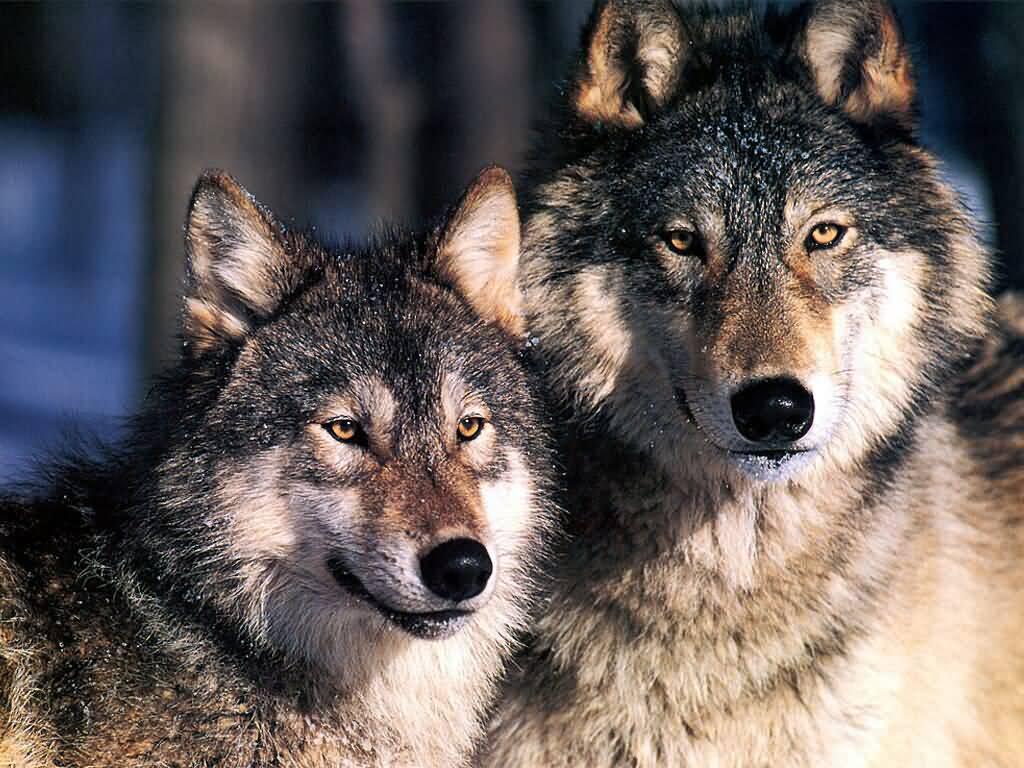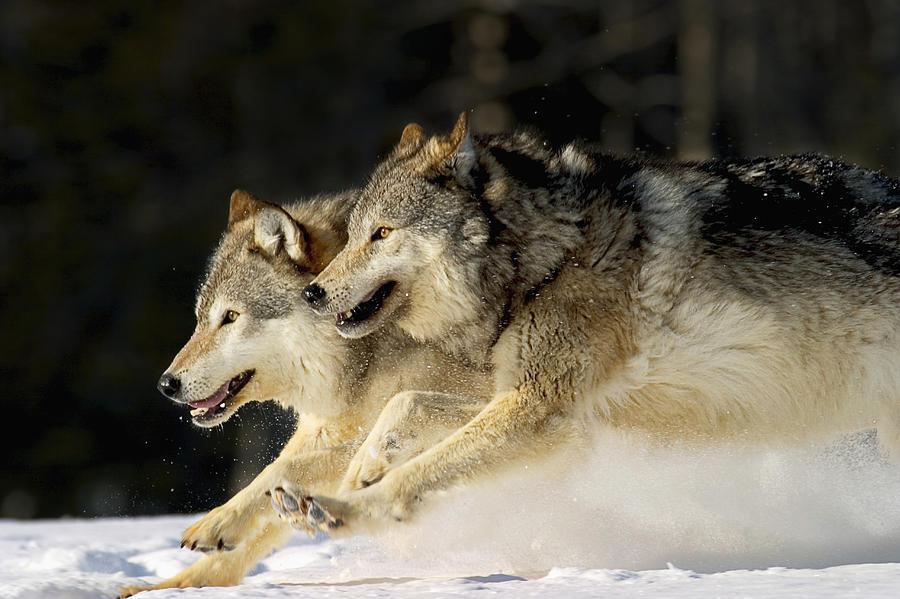The first image is the image on the left, the second image is the image on the right. For the images displayed, is the sentence "At least one of the dogs is lying on the ground." factually correct? Answer yes or no. No. The first image is the image on the left, the second image is the image on the right. Considering the images on both sides, is "The right image shows one wolf standing over another wolf that is lying on its back with its rear to the camera and multiple paws in the air." valid? Answer yes or no. No. 